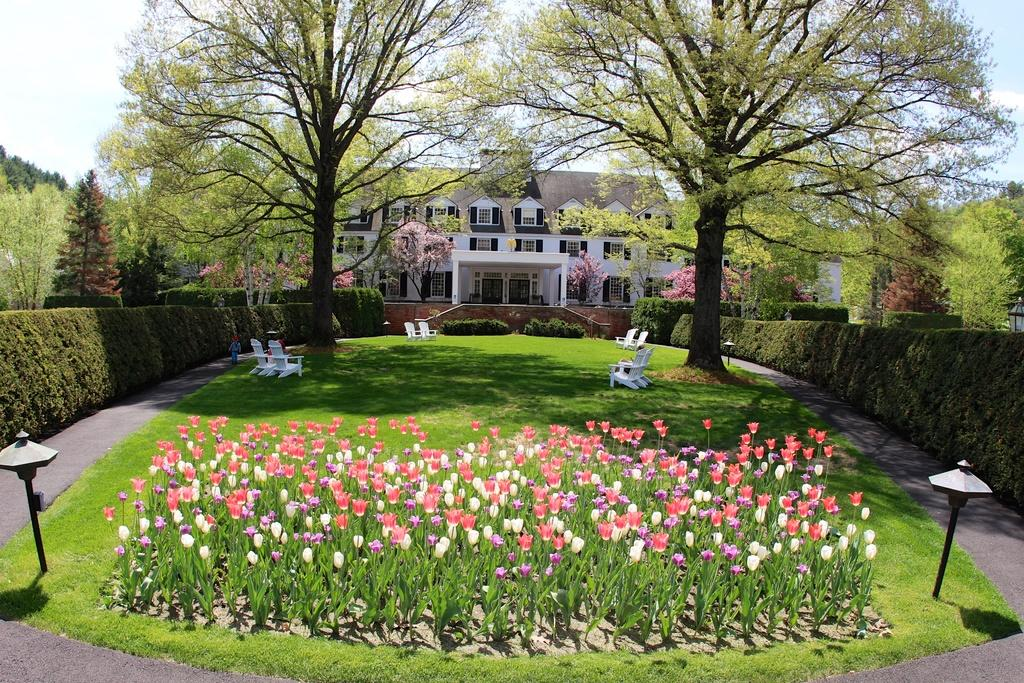What type of living organisms can be seen in the image? Plants and flowers are visible in the image. What can be seen in the background of the image? There are trees, chairs, grass, plants, and windows in the background of the image. Can any structures be identified in the image? Yes, there is a building present in the background of the image. What type of rhythm can be heard coming from the quince in the image? There is no quince present in the image, and therefore no rhythm can be heard. What type of brick is used to construct the building in the image? The image does not provide enough detail to determine the type of brick used in the construction of the building. 